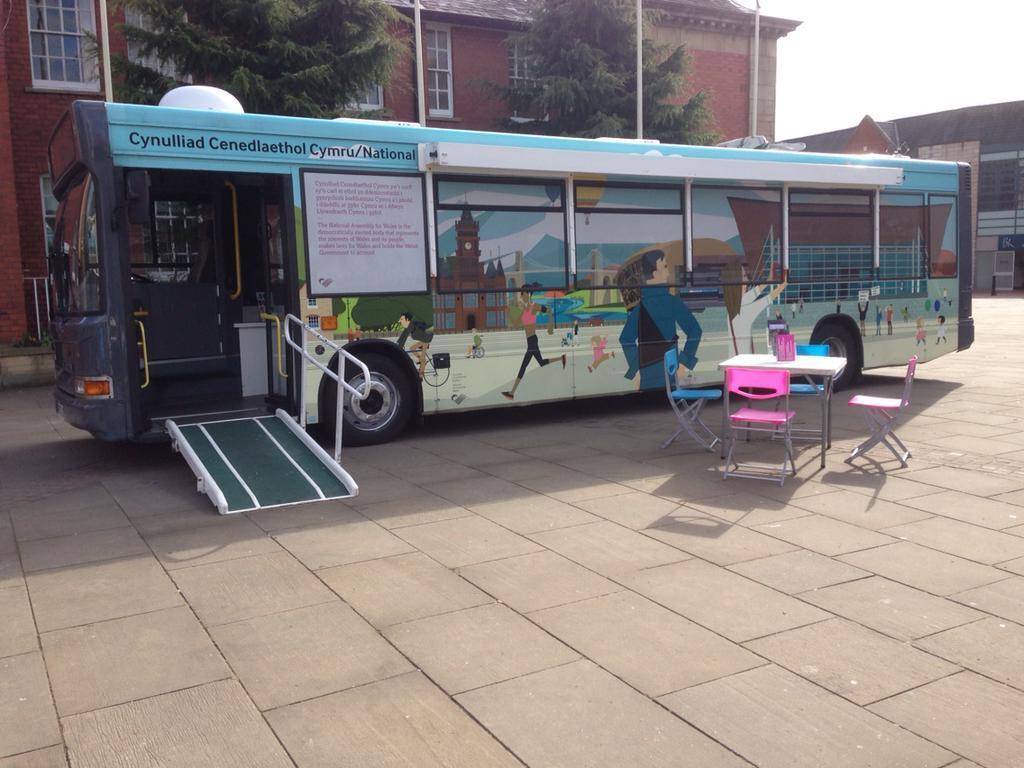How would you summarize this image in a sentence or two? In this image we can see the bus parked on the path. We can also see a table with four chairs and there is an object on the table. In the background we can see the buildings, trees and also the sky. We can also see the poles. 